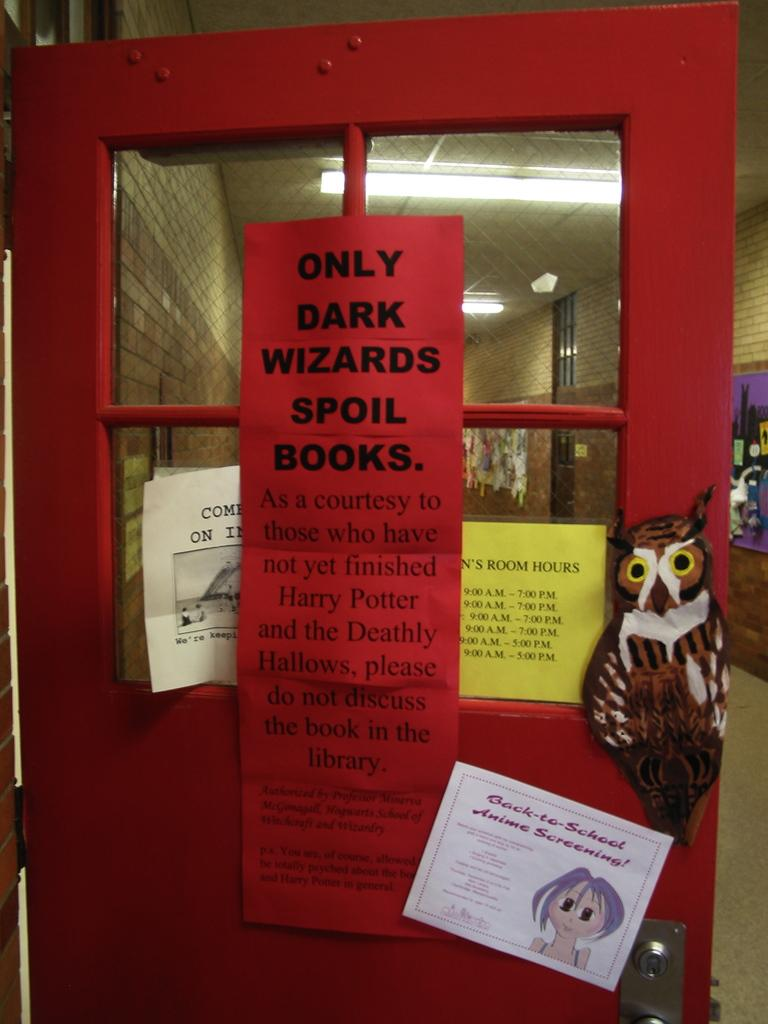<image>
Create a compact narrative representing the image presented. A red door with windows and a sign posted on it that reads Only Dark Wizards Spoil Books. 